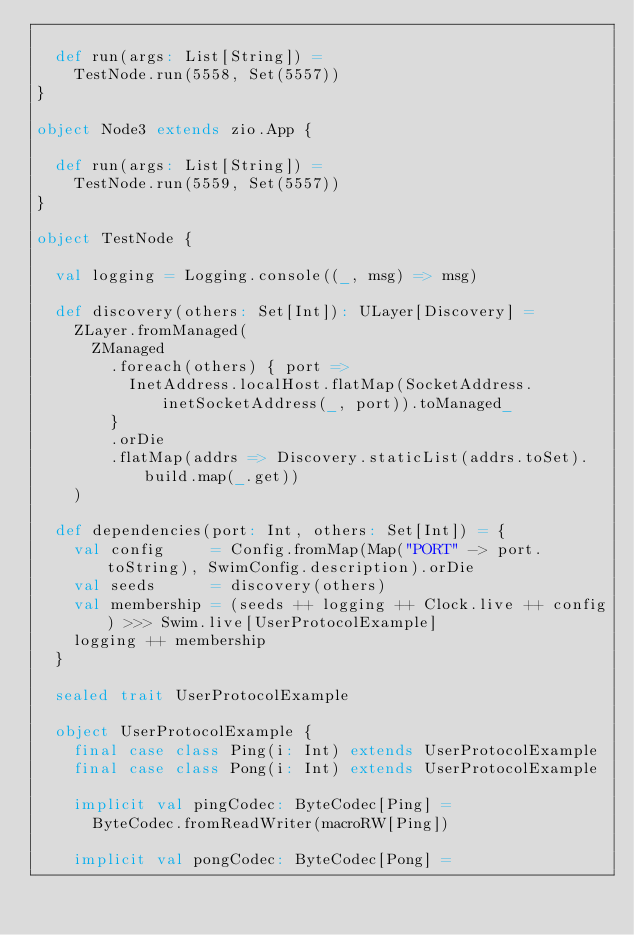Convert code to text. <code><loc_0><loc_0><loc_500><loc_500><_Scala_>
  def run(args: List[String]) =
    TestNode.run(5558, Set(5557))
}

object Node3 extends zio.App {

  def run(args: List[String]) =
    TestNode.run(5559, Set(5557))
}

object TestNode {

  val logging = Logging.console((_, msg) => msg)

  def discovery(others: Set[Int]): ULayer[Discovery] =
    ZLayer.fromManaged(
      ZManaged
        .foreach(others) { port =>
          InetAddress.localHost.flatMap(SocketAddress.inetSocketAddress(_, port)).toManaged_
        }
        .orDie
        .flatMap(addrs => Discovery.staticList(addrs.toSet).build.map(_.get))
    )

  def dependencies(port: Int, others: Set[Int]) = {
    val config     = Config.fromMap(Map("PORT" -> port.toString), SwimConfig.description).orDie
    val seeds      = discovery(others)
    val membership = (seeds ++ logging ++ Clock.live ++ config) >>> Swim.live[UserProtocolExample]
    logging ++ membership
  }

  sealed trait UserProtocolExample

  object UserProtocolExample {
    final case class Ping(i: Int) extends UserProtocolExample
    final case class Pong(i: Int) extends UserProtocolExample

    implicit val pingCodec: ByteCodec[Ping] =
      ByteCodec.fromReadWriter(macroRW[Ping])

    implicit val pongCodec: ByteCodec[Pong] =</code> 